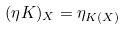<formula> <loc_0><loc_0><loc_500><loc_500>( \eta K ) _ { X } = \eta _ { K ( X ) }</formula> 